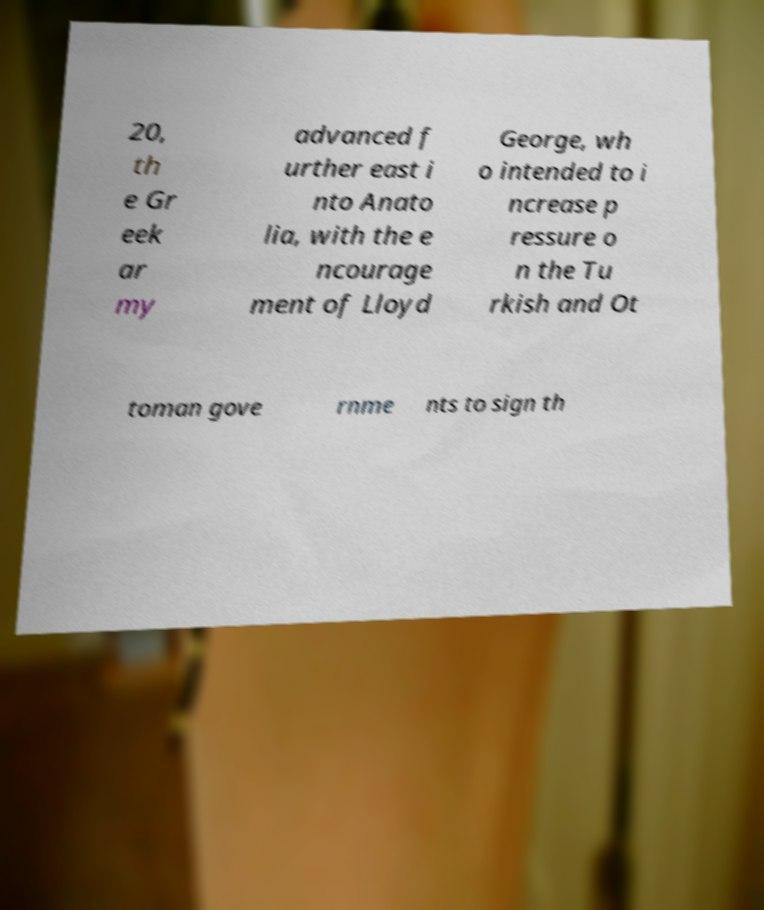Please read and relay the text visible in this image. What does it say? 20, th e Gr eek ar my advanced f urther east i nto Anato lia, with the e ncourage ment of Lloyd George, wh o intended to i ncrease p ressure o n the Tu rkish and Ot toman gove rnme nts to sign th 